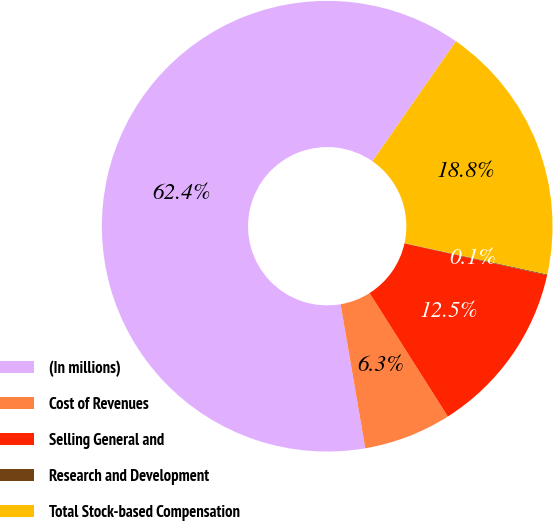Convert chart. <chart><loc_0><loc_0><loc_500><loc_500><pie_chart><fcel>(In millions)<fcel>Cost of Revenues<fcel>Selling General and<fcel>Research and Development<fcel>Total Stock-based Compensation<nl><fcel>62.38%<fcel>6.29%<fcel>12.52%<fcel>0.06%<fcel>18.75%<nl></chart> 